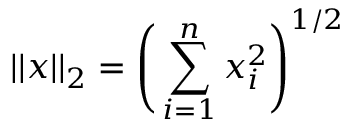<formula> <loc_0><loc_0><loc_500><loc_500>| | x | | _ { 2 } = \left ( \sum _ { i = 1 } ^ { n } x _ { i } ^ { 2 } \right ) ^ { 1 / 2 }</formula> 